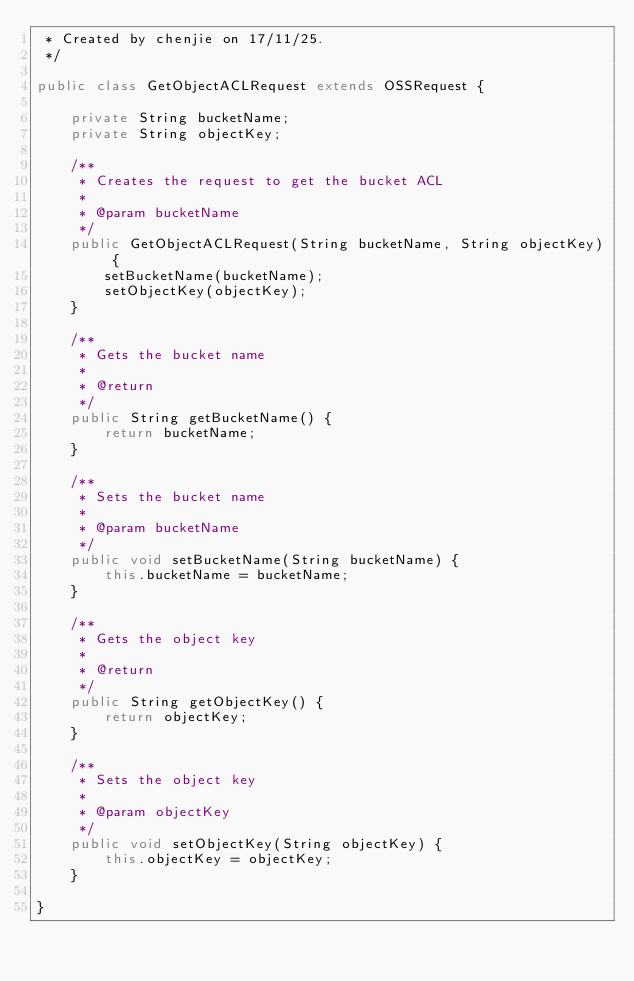Convert code to text. <code><loc_0><loc_0><loc_500><loc_500><_Java_> * Created by chenjie on 17/11/25.
 */

public class GetObjectACLRequest extends OSSRequest {

    private String bucketName;
    private String objectKey;

    /**
     * Creates the request to get the bucket ACL
     *
     * @param bucketName
     */
    public GetObjectACLRequest(String bucketName, String objectKey) {
        setBucketName(bucketName);
        setObjectKey(objectKey);
    }

    /**
     * Gets the bucket name
     *
     * @return
     */
    public String getBucketName() {
        return bucketName;
    }

    /**
     * Sets the bucket name
     *
     * @param bucketName
     */
    public void setBucketName(String bucketName) {
        this.bucketName = bucketName;
    }

    /**
     * Gets the object key
     *
     * @return
     */
    public String getObjectKey() {
        return objectKey;
    }

    /**
     * Sets the object key
     *
     * @param objectKey
     */
    public void setObjectKey(String objectKey) {
        this.objectKey = objectKey;
    }

}
</code> 